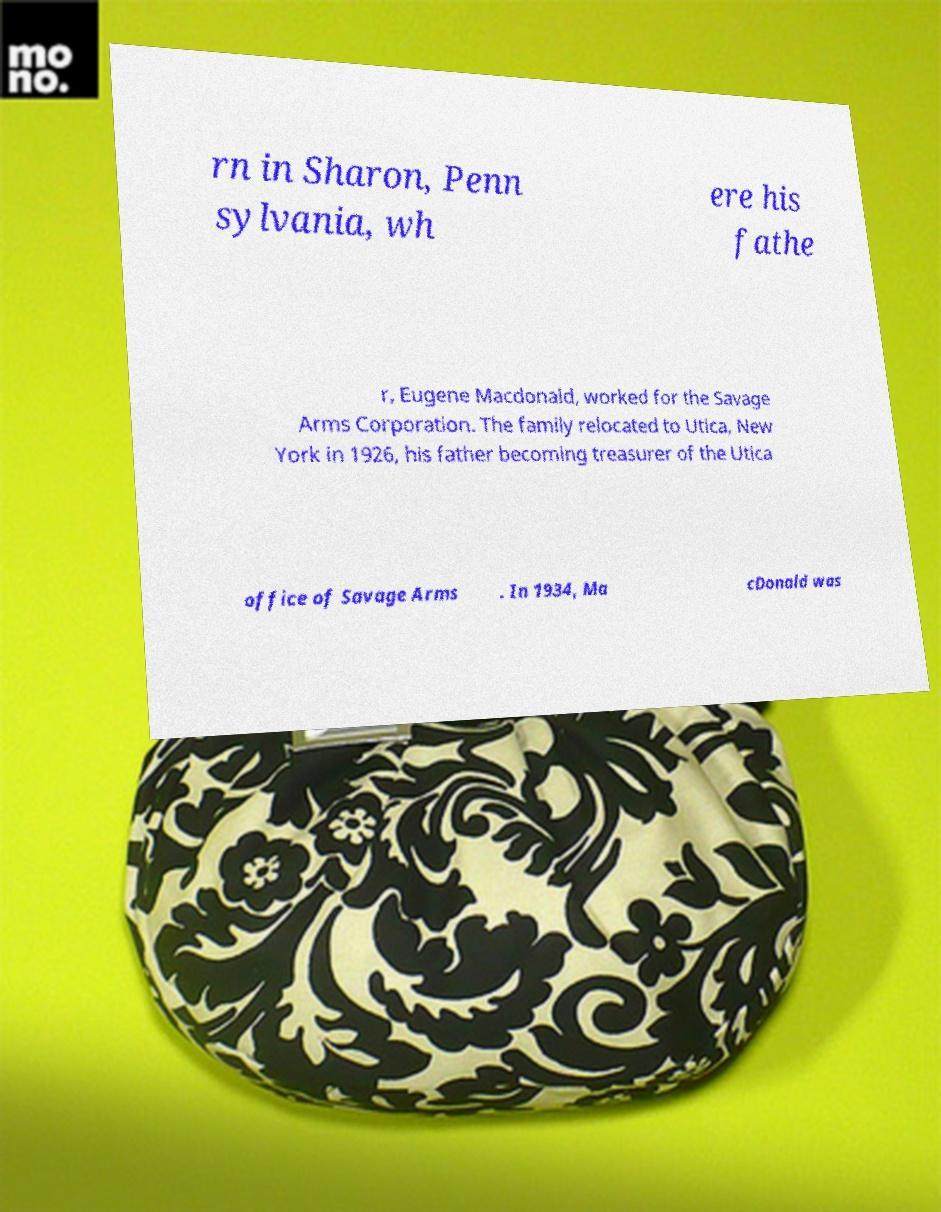There's text embedded in this image that I need extracted. Can you transcribe it verbatim? rn in Sharon, Penn sylvania, wh ere his fathe r, Eugene Macdonald, worked for the Savage Arms Corporation. The family relocated to Utica, New York in 1926, his father becoming treasurer of the Utica office of Savage Arms . In 1934, Ma cDonald was 